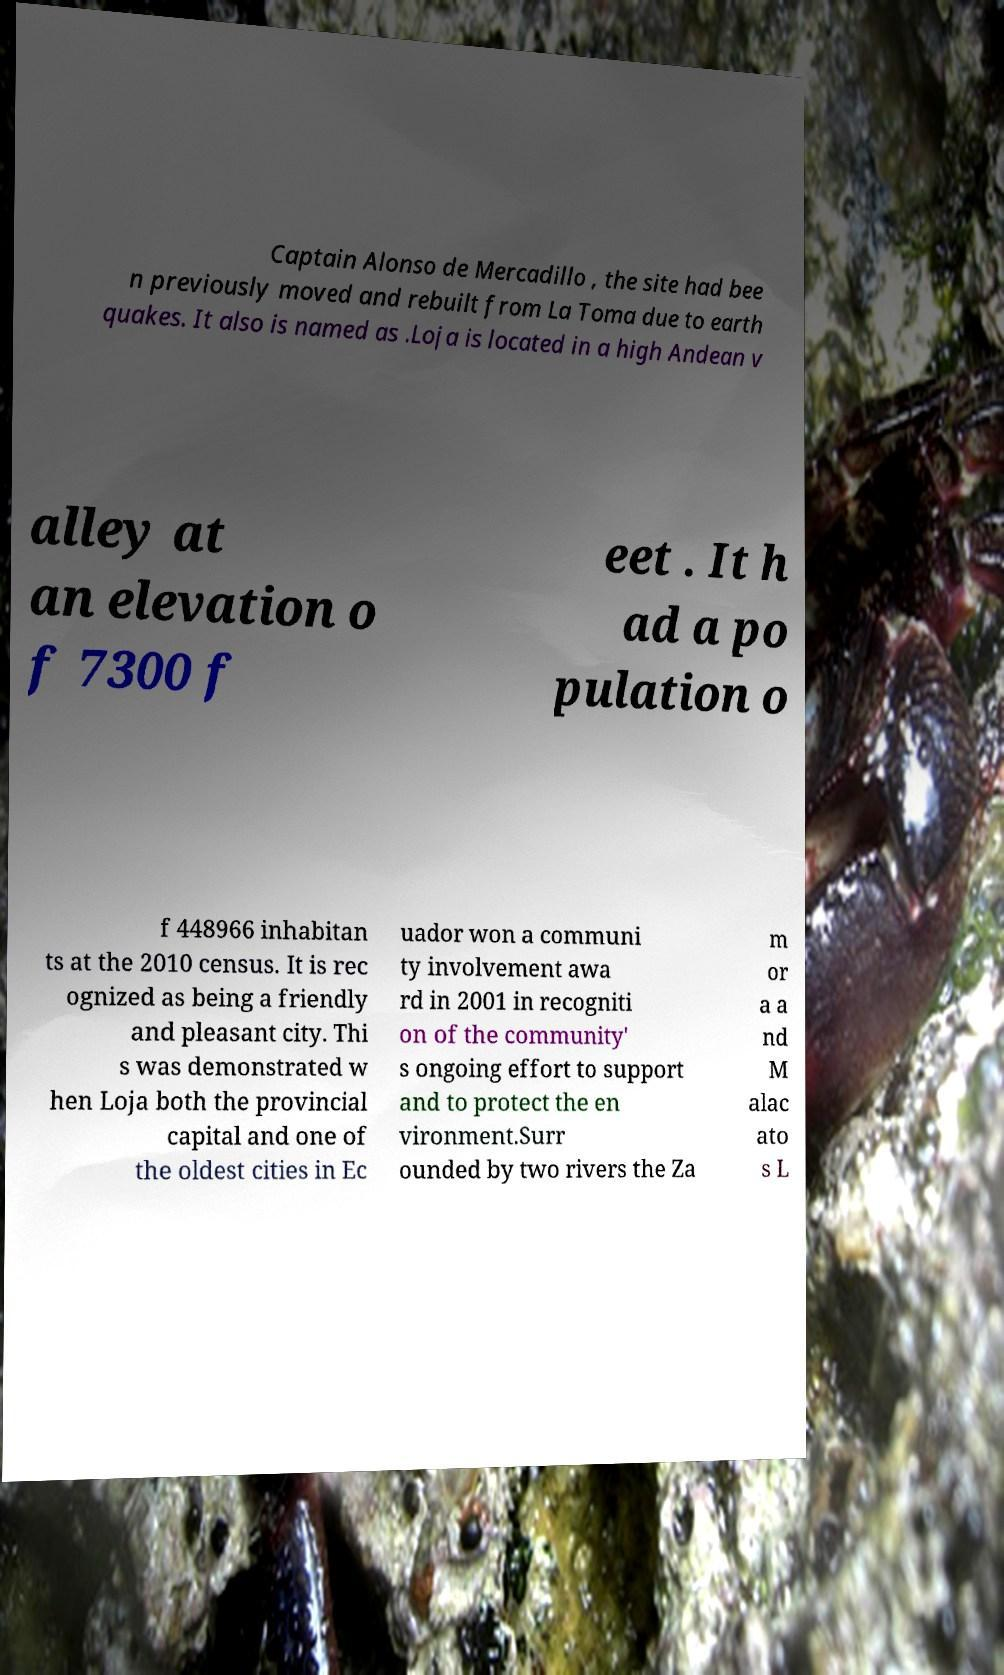Please identify and transcribe the text found in this image. Captain Alonso de Mercadillo , the site had bee n previously moved and rebuilt from La Toma due to earth quakes. It also is named as .Loja is located in a high Andean v alley at an elevation o f 7300 f eet . It h ad a po pulation o f 448966 inhabitan ts at the 2010 census. It is rec ognized as being a friendly and pleasant city. Thi s was demonstrated w hen Loja both the provincial capital and one of the oldest cities in Ec uador won a communi ty involvement awa rd in 2001 in recogniti on of the community' s ongoing effort to support and to protect the en vironment.Surr ounded by two rivers the Za m or a a nd M alac ato s L 